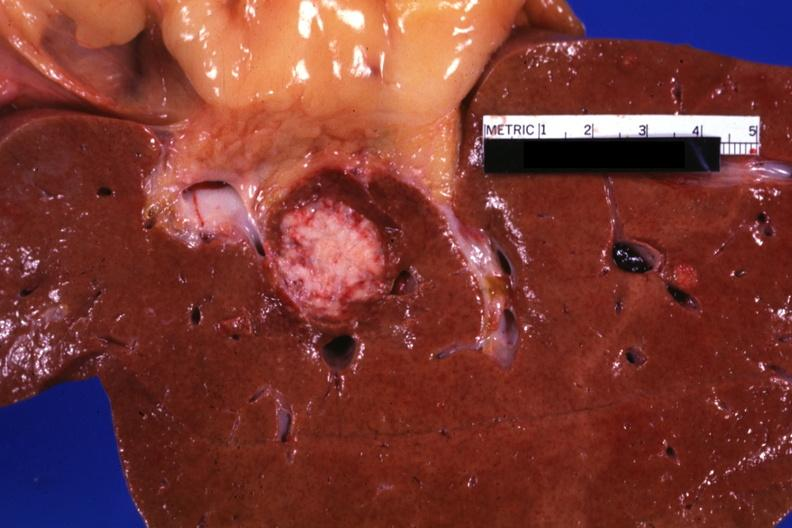s papillary adenoma present?
Answer the question using a single word or phrase. No 